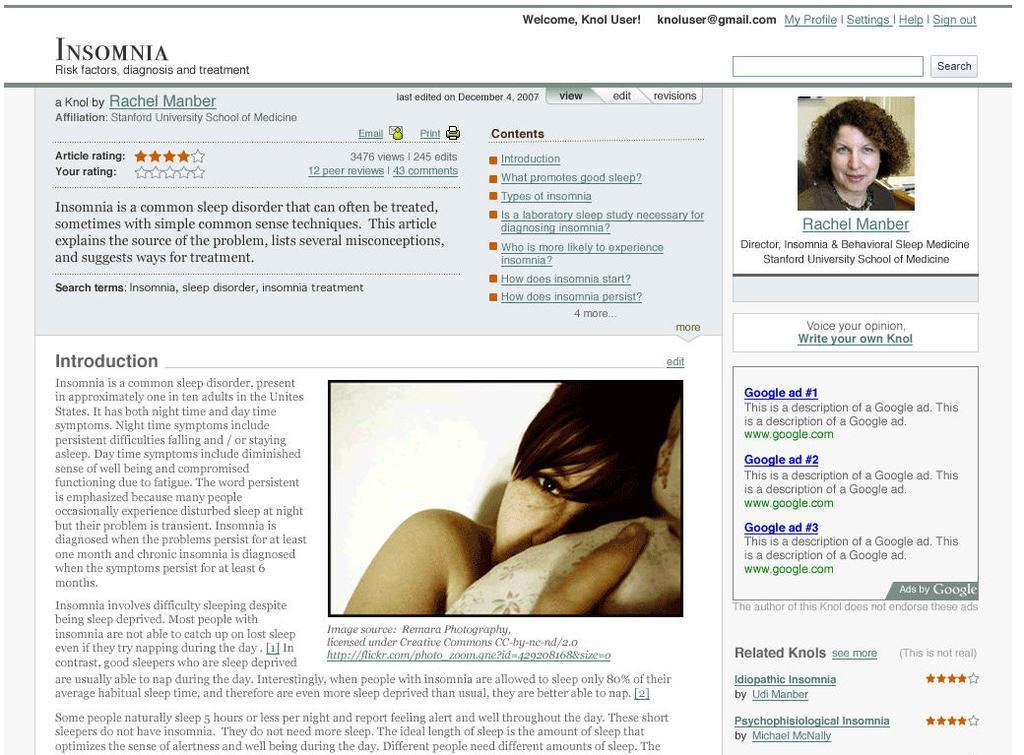Can you describe this image briefly? In this image I can see a website page, where on the top right side and in the centre I can see two women. I can also see something is written on this page. 